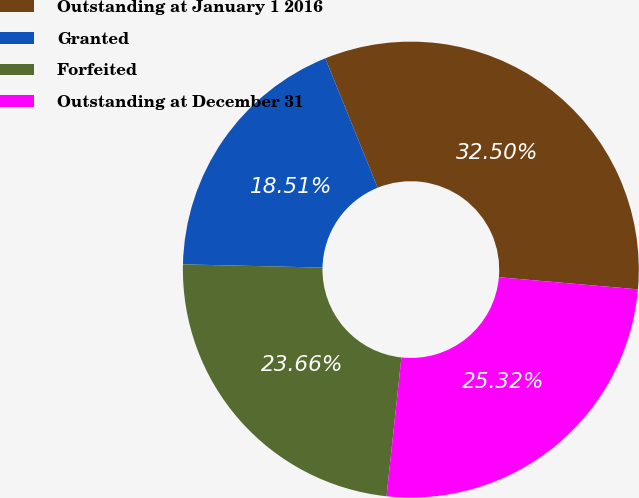<chart> <loc_0><loc_0><loc_500><loc_500><pie_chart><fcel>Outstanding at January 1 2016<fcel>Granted<fcel>Forfeited<fcel>Outstanding at December 31<nl><fcel>32.5%<fcel>18.51%<fcel>23.66%<fcel>25.32%<nl></chart> 